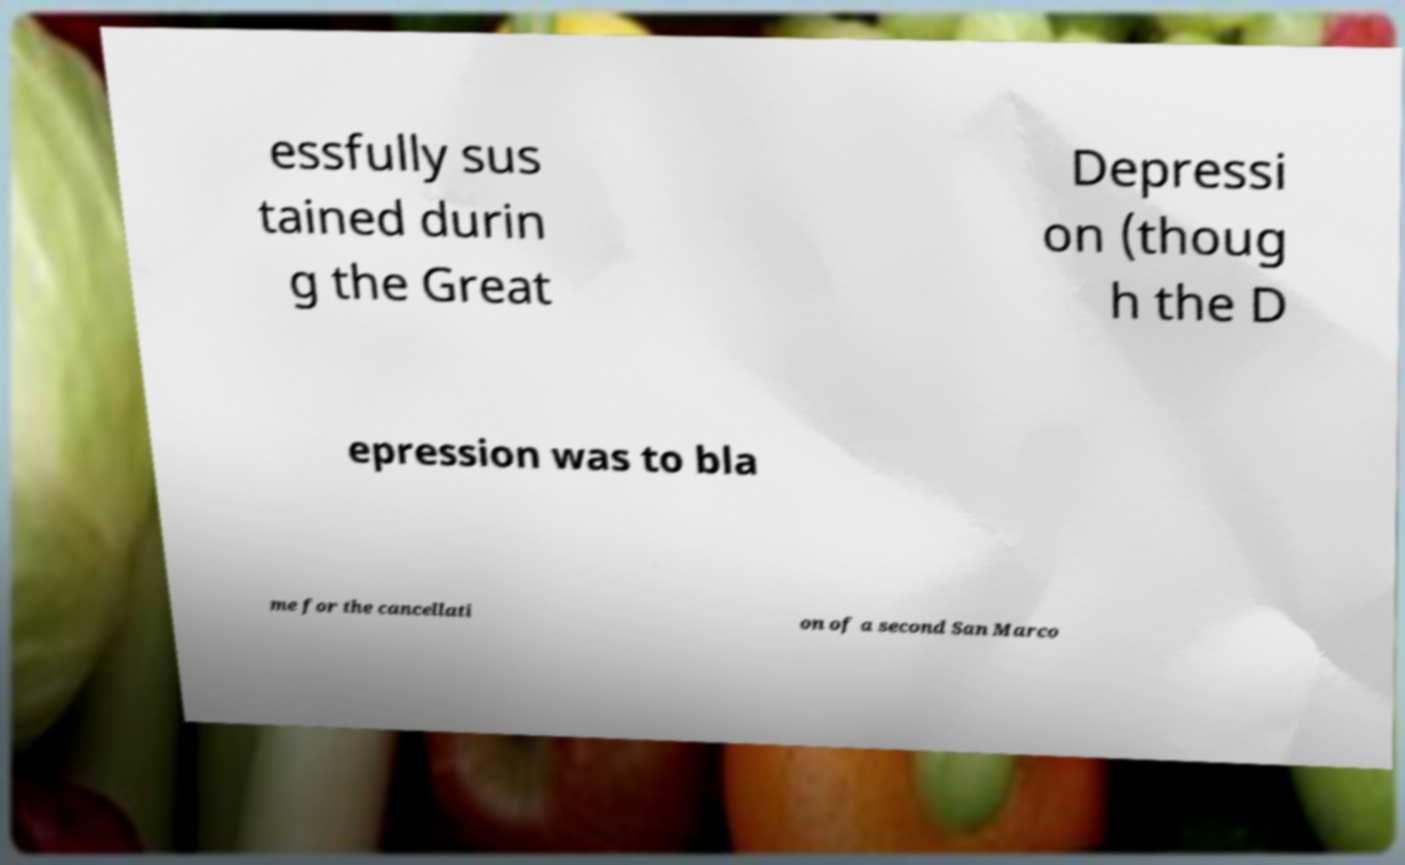I need the written content from this picture converted into text. Can you do that? essfully sus tained durin g the Great Depressi on (thoug h the D epression was to bla me for the cancellati on of a second San Marco 